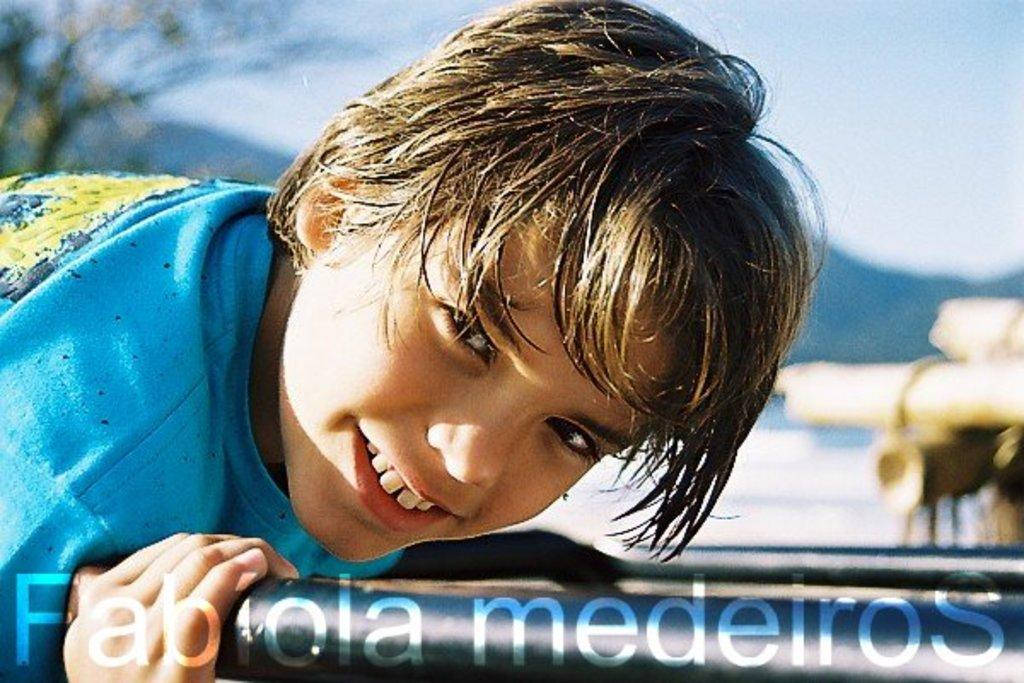Who is the main subject in the image? There is a boy in the image. What is the boy holding in the image? The boy is holding an object. What can be seen in the background on the left side? There is a tree in the background on the left side. What type of natural formation is visible in the background? There are mountains visible in the background. What else can be seen in the background on the right side? There are objects on the right side in the background. What is visible in the sky in the background? The sky is visible in the background. How many wrens are perched on the boy's shoulder in the image? There are no wrens present in the image. What type of mass is being measured by the boy in the image? The boy is not measuring any mass in the image; he is holding an object. 